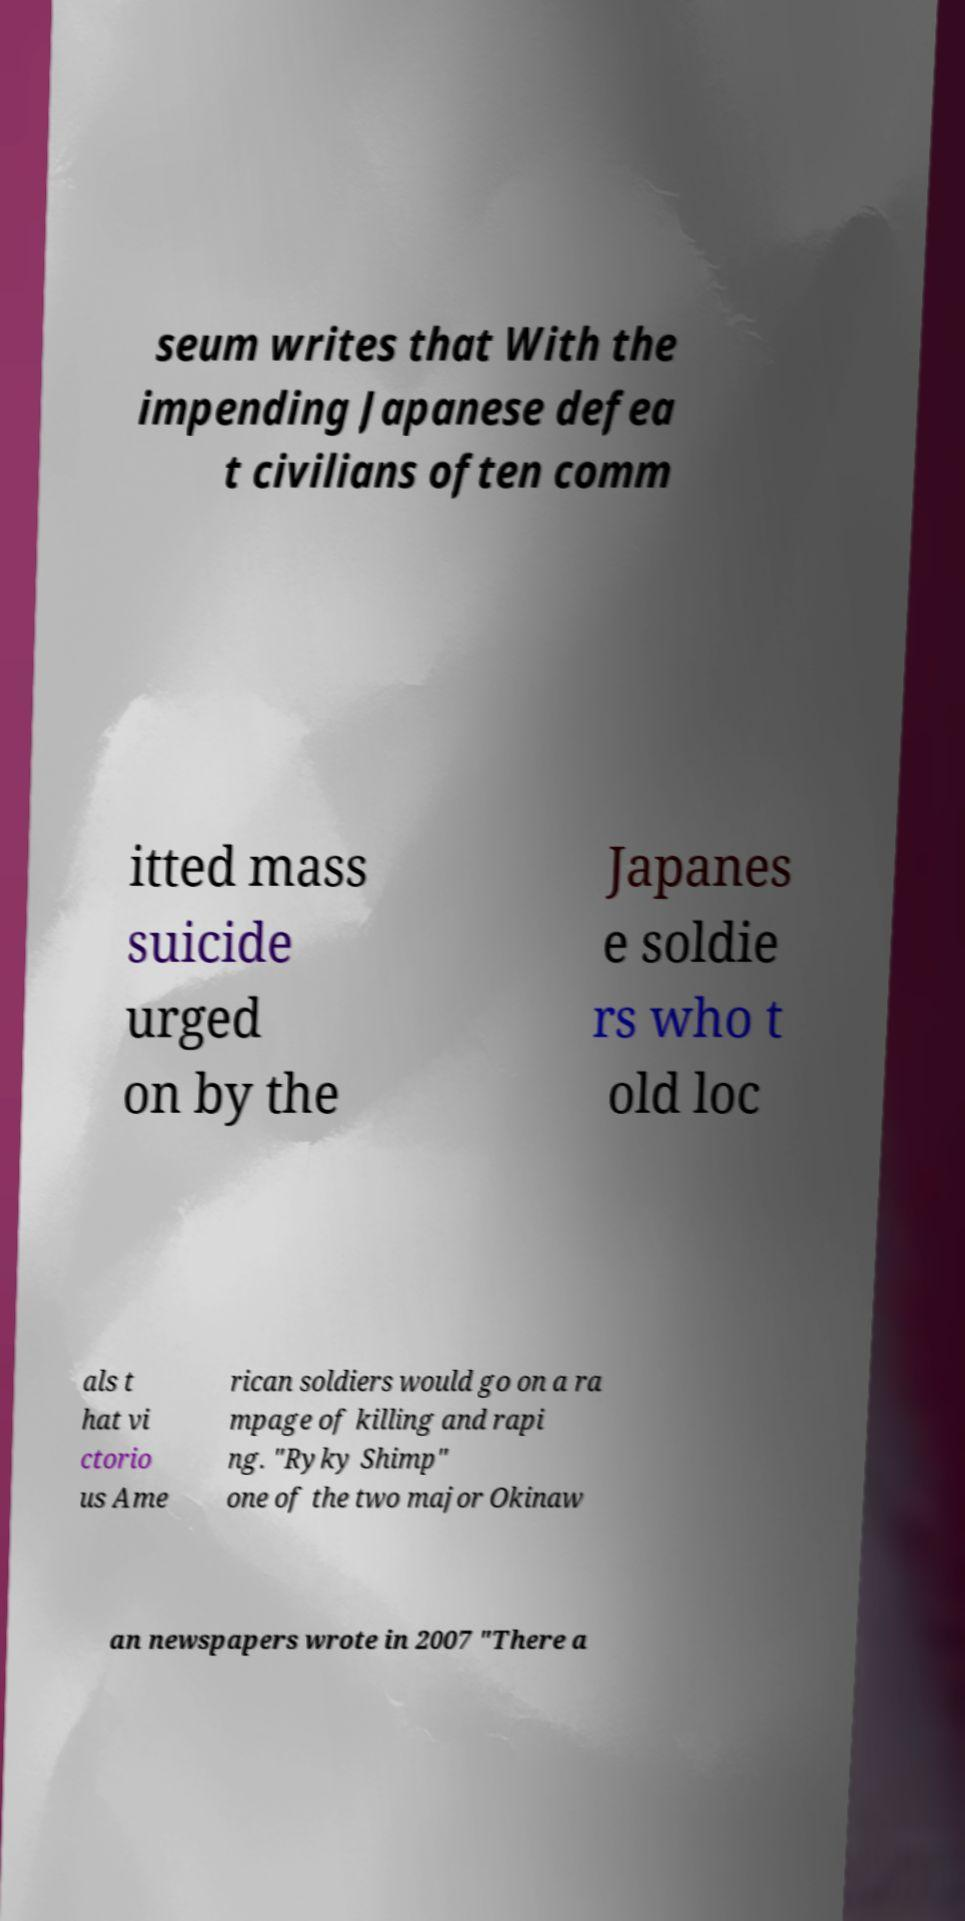Can you accurately transcribe the text from the provided image for me? seum writes that With the impending Japanese defea t civilians often comm itted mass suicide urged on by the Japanes e soldie rs who t old loc als t hat vi ctorio us Ame rican soldiers would go on a ra mpage of killing and rapi ng. "Ryky Shimp" one of the two major Okinaw an newspapers wrote in 2007 "There a 